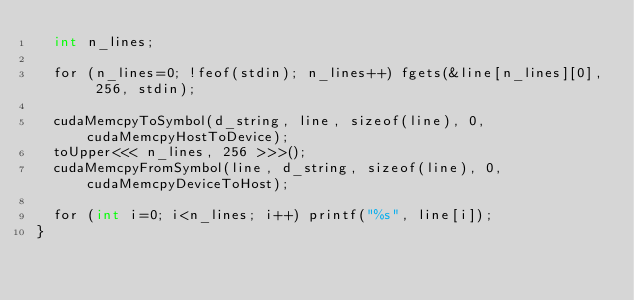<code> <loc_0><loc_0><loc_500><loc_500><_Cuda_>  int n_lines;

  for (n_lines=0; !feof(stdin); n_lines++) fgets(&line[n_lines][0], 256, stdin);

  cudaMemcpyToSymbol(d_string, line, sizeof(line), 0, cudaMemcpyHostToDevice);
  toUpper<<< n_lines, 256 >>>();
  cudaMemcpyFromSymbol(line, d_string, sizeof(line), 0, cudaMemcpyDeviceToHost);

  for (int i=0; i<n_lines; i++) printf("%s", line[i]);
}
</code> 